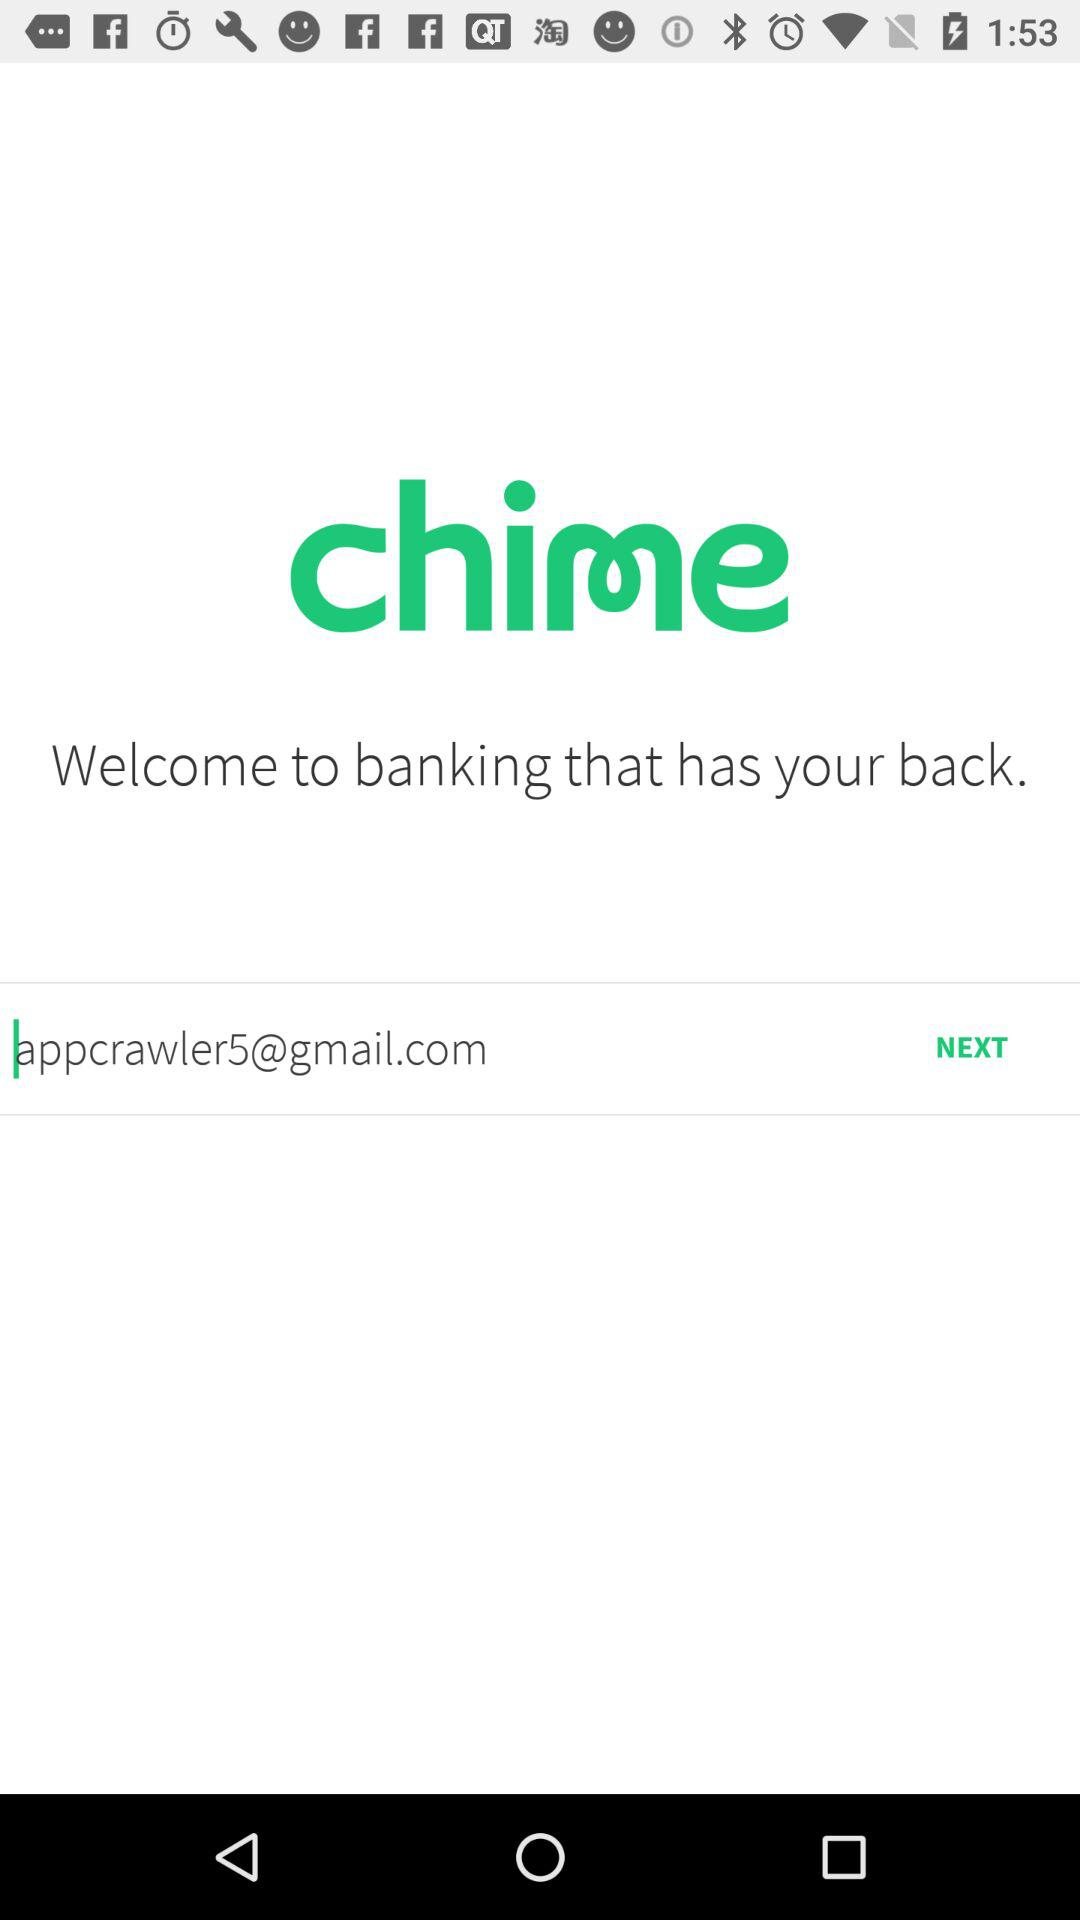What is the application name? The application name is "chime". 